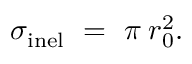<formula> <loc_0><loc_0><loc_500><loc_500>\sigma _ { i n e l } \ = \ \pi \, r _ { 0 } ^ { 2 } .</formula> 